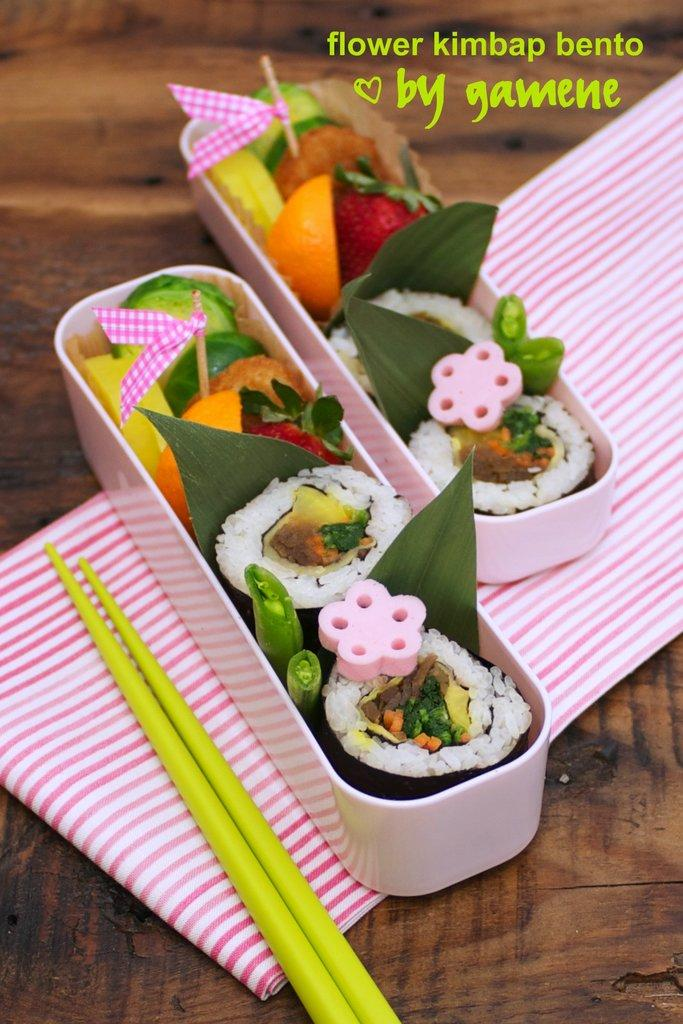What type of food is accompanied by toothpicks in the image? The facts do not specify the type of food, only that there is food with toothpicks in the image. What is placed under the food tray in the image? There is a cloth under the food tray in the image. What color are the chopsticks in the image? The chopsticks in the image are green. What type of surface is visible in the image? The wooden surface is visible in the image. Is there a line of people waiting to claim their property in the image? There is no mention of a line of people or property in the image; it features food with toothpicks, a cloth, green chopsticks, and a wooden surface. 